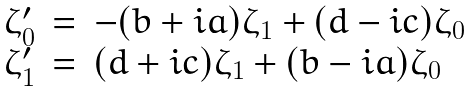Convert formula to latex. <formula><loc_0><loc_0><loc_500><loc_500>\begin{array} { r c l } \zeta ^ { \prime } _ { 0 } & = & - ( b + i a ) \zeta _ { 1 } + ( d - i c ) \zeta _ { 0 } \\ \zeta ^ { \prime } _ { 1 } & = & ( d + i c ) \zeta _ { 1 } + ( b - i a ) \zeta _ { 0 } \\ \end{array}</formula> 